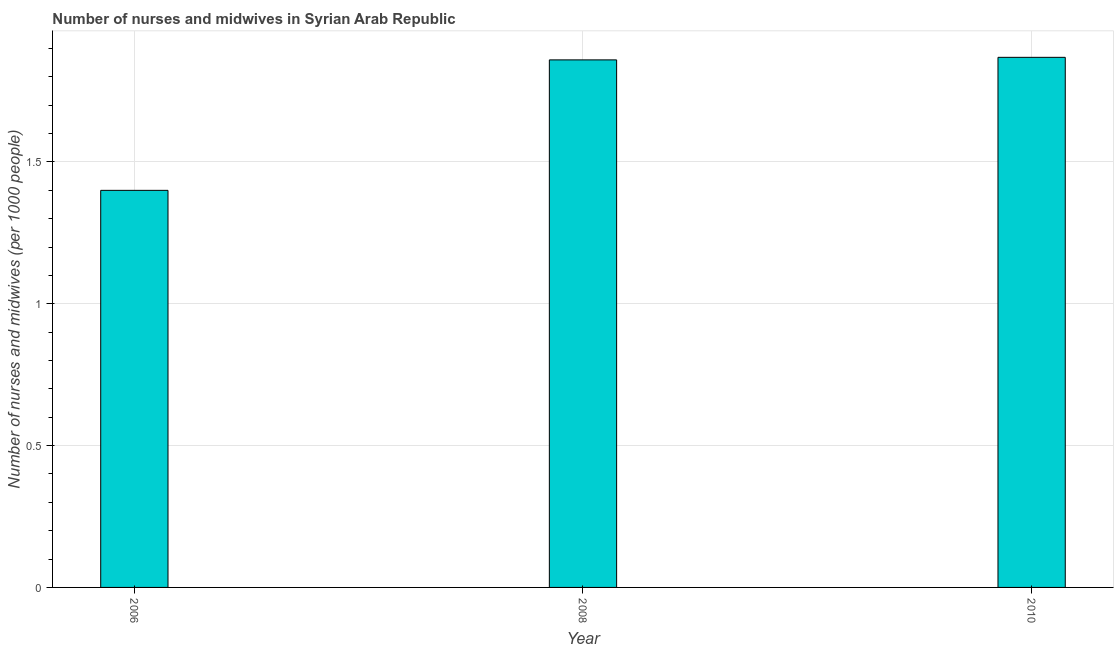What is the title of the graph?
Keep it short and to the point. Number of nurses and midwives in Syrian Arab Republic. What is the label or title of the X-axis?
Keep it short and to the point. Year. What is the label or title of the Y-axis?
Offer a terse response. Number of nurses and midwives (per 1000 people). What is the number of nurses and midwives in 2006?
Your answer should be compact. 1.4. Across all years, what is the maximum number of nurses and midwives?
Provide a succinct answer. 1.87. In which year was the number of nurses and midwives maximum?
Provide a succinct answer. 2010. What is the sum of the number of nurses and midwives?
Keep it short and to the point. 5.13. What is the difference between the number of nurses and midwives in 2006 and 2008?
Your answer should be compact. -0.46. What is the average number of nurses and midwives per year?
Give a very brief answer. 1.71. What is the median number of nurses and midwives?
Your response must be concise. 1.86. In how many years, is the number of nurses and midwives greater than 1.1 ?
Ensure brevity in your answer.  3. What is the ratio of the number of nurses and midwives in 2006 to that in 2008?
Provide a succinct answer. 0.75. What is the difference between the highest and the second highest number of nurses and midwives?
Provide a short and direct response. 0.01. What is the difference between the highest and the lowest number of nurses and midwives?
Your answer should be very brief. 0.47. How many bars are there?
Ensure brevity in your answer.  3. Are all the bars in the graph horizontal?
Your answer should be compact. No. How many years are there in the graph?
Offer a terse response. 3. What is the Number of nurses and midwives (per 1000 people) in 2008?
Provide a succinct answer. 1.86. What is the Number of nurses and midwives (per 1000 people) of 2010?
Give a very brief answer. 1.87. What is the difference between the Number of nurses and midwives (per 1000 people) in 2006 and 2008?
Make the answer very short. -0.46. What is the difference between the Number of nurses and midwives (per 1000 people) in 2006 and 2010?
Keep it short and to the point. -0.47. What is the difference between the Number of nurses and midwives (per 1000 people) in 2008 and 2010?
Keep it short and to the point. -0.01. What is the ratio of the Number of nurses and midwives (per 1000 people) in 2006 to that in 2008?
Offer a very short reply. 0.75. What is the ratio of the Number of nurses and midwives (per 1000 people) in 2006 to that in 2010?
Give a very brief answer. 0.75. What is the ratio of the Number of nurses and midwives (per 1000 people) in 2008 to that in 2010?
Ensure brevity in your answer.  0.99. 